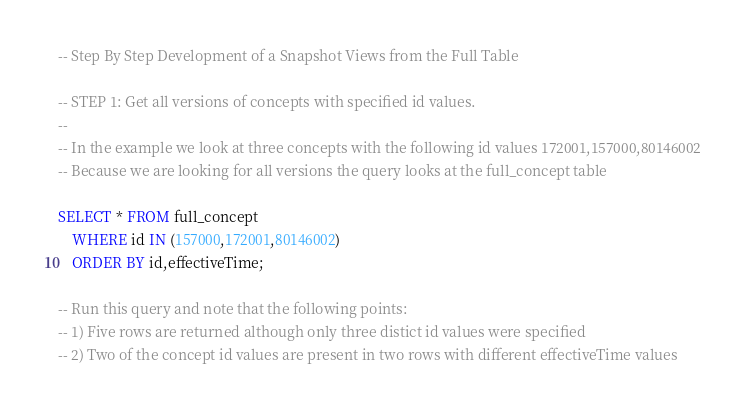Convert code to text. <code><loc_0><loc_0><loc_500><loc_500><_SQL_>-- Step By Step Development of a Snapshot Views from the Full Table

-- STEP 1: Get all versions of concepts with specified id values.
--
-- In the example we look at three concepts with the following id values 172001,157000,80146002
-- Because we are looking for all versions the query looks at the full_concept table

SELECT * FROM full_concept  
    WHERE id IN (157000,172001,80146002) 
    ORDER BY id,effectiveTime;

-- Run this query and note that the following points:
-- 1) Five rows are returned although only three distict id values were specified
-- 2) Two of the concept id values are present in two rows with different effectiveTime values</code> 